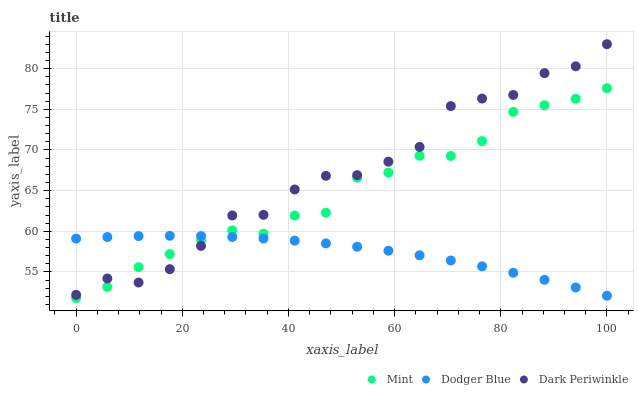Does Dodger Blue have the minimum area under the curve?
Answer yes or no. Yes. Does Dark Periwinkle have the maximum area under the curve?
Answer yes or no. Yes. Does Mint have the minimum area under the curve?
Answer yes or no. No. Does Mint have the maximum area under the curve?
Answer yes or no. No. Is Dodger Blue the smoothest?
Answer yes or no. Yes. Is Dark Periwinkle the roughest?
Answer yes or no. Yes. Is Mint the smoothest?
Answer yes or no. No. Is Mint the roughest?
Answer yes or no. No. Does Mint have the lowest value?
Answer yes or no. Yes. Does Dark Periwinkle have the lowest value?
Answer yes or no. No. Does Dark Periwinkle have the highest value?
Answer yes or no. Yes. Does Mint have the highest value?
Answer yes or no. No. Does Dark Periwinkle intersect Dodger Blue?
Answer yes or no. Yes. Is Dark Periwinkle less than Dodger Blue?
Answer yes or no. No. Is Dark Periwinkle greater than Dodger Blue?
Answer yes or no. No. 